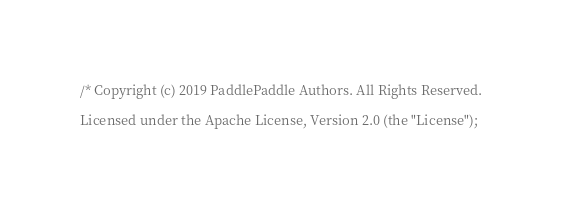Convert code to text. <code><loc_0><loc_0><loc_500><loc_500><_Cuda_>/* Copyright (c) 2019 PaddlePaddle Authors. All Rights Reserved.

Licensed under the Apache License, Version 2.0 (the "License");</code> 